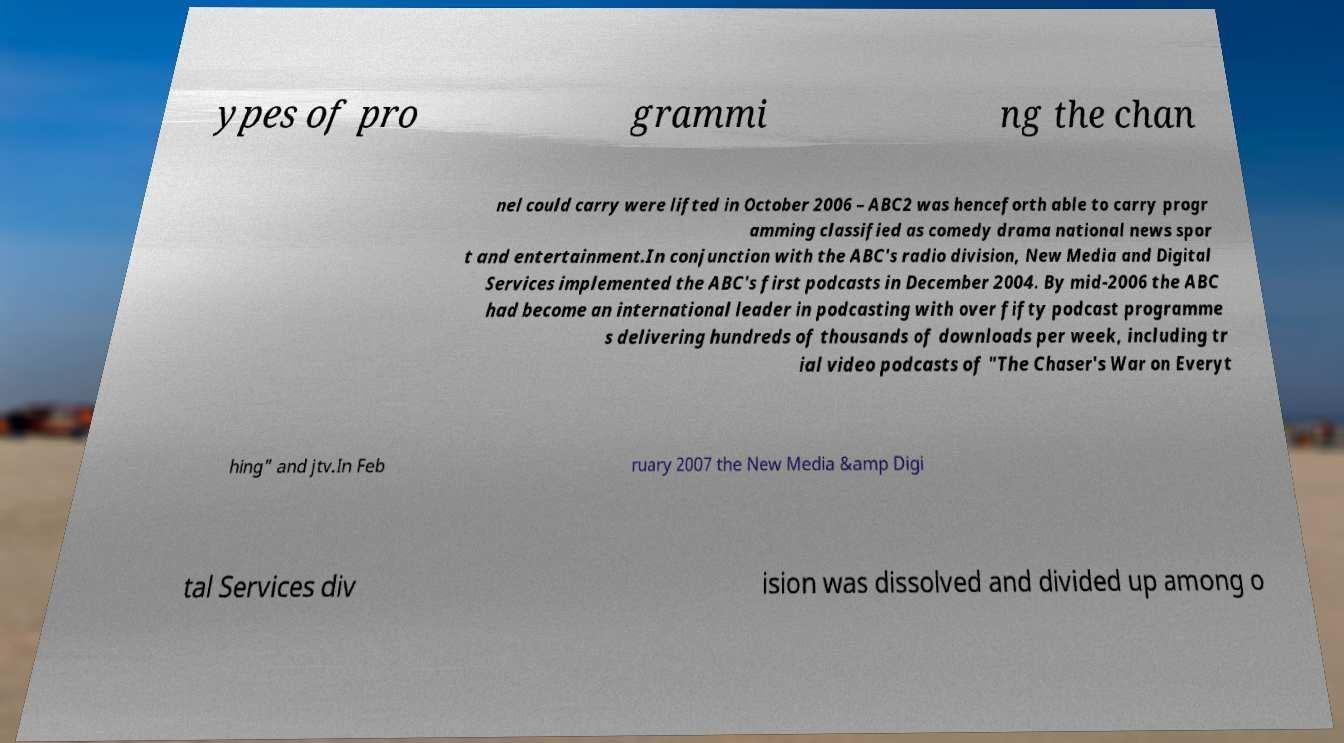Can you accurately transcribe the text from the provided image for me? ypes of pro grammi ng the chan nel could carry were lifted in October 2006 – ABC2 was henceforth able to carry progr amming classified as comedy drama national news spor t and entertainment.In conjunction with the ABC's radio division, New Media and Digital Services implemented the ABC's first podcasts in December 2004. By mid-2006 the ABC had become an international leader in podcasting with over fifty podcast programme s delivering hundreds of thousands of downloads per week, including tr ial video podcasts of "The Chaser's War on Everyt hing" and jtv.In Feb ruary 2007 the New Media &amp Digi tal Services div ision was dissolved and divided up among o 